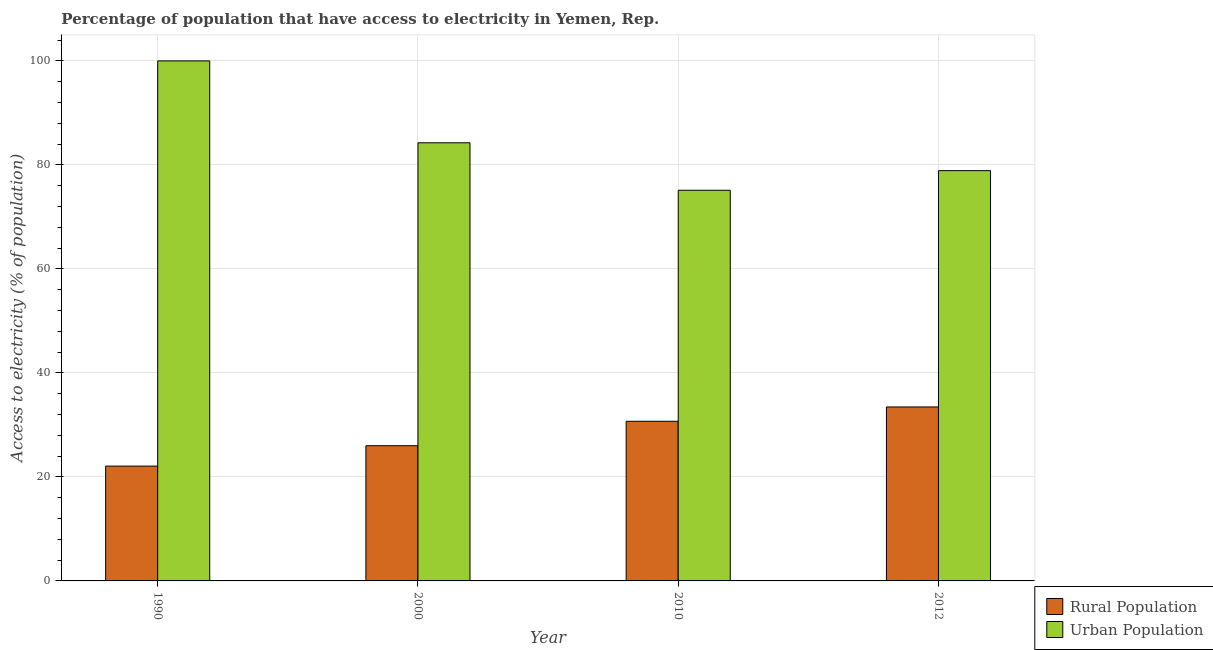Are the number of bars on each tick of the X-axis equal?
Offer a terse response. Yes. How many bars are there on the 1st tick from the left?
Your response must be concise. 2. In how many cases, is the number of bars for a given year not equal to the number of legend labels?
Provide a succinct answer. 0. What is the percentage of urban population having access to electricity in 2012?
Provide a short and direct response. 78.89. Across all years, what is the minimum percentage of rural population having access to electricity?
Ensure brevity in your answer.  22.08. What is the total percentage of urban population having access to electricity in the graph?
Offer a terse response. 338.26. What is the difference between the percentage of rural population having access to electricity in 2010 and that in 2012?
Your answer should be compact. -2.75. What is the difference between the percentage of rural population having access to electricity in 1990 and the percentage of urban population having access to electricity in 2000?
Offer a terse response. -3.92. What is the average percentage of rural population having access to electricity per year?
Offer a terse response. 28.06. What is the ratio of the percentage of rural population having access to electricity in 1990 to that in 2012?
Ensure brevity in your answer.  0.66. Is the percentage of rural population having access to electricity in 2000 less than that in 2010?
Keep it short and to the point. Yes. Is the difference between the percentage of urban population having access to electricity in 2000 and 2010 greater than the difference between the percentage of rural population having access to electricity in 2000 and 2010?
Offer a terse response. No. What is the difference between the highest and the second highest percentage of urban population having access to electricity?
Offer a very short reply. 15.75. What is the difference between the highest and the lowest percentage of urban population having access to electricity?
Keep it short and to the point. 24.88. In how many years, is the percentage of rural population having access to electricity greater than the average percentage of rural population having access to electricity taken over all years?
Keep it short and to the point. 2. What does the 1st bar from the left in 2012 represents?
Ensure brevity in your answer.  Rural Population. What does the 1st bar from the right in 2000 represents?
Keep it short and to the point. Urban Population. How many bars are there?
Keep it short and to the point. 8. How many years are there in the graph?
Offer a very short reply. 4. What is the difference between two consecutive major ticks on the Y-axis?
Provide a succinct answer. 20. Are the values on the major ticks of Y-axis written in scientific E-notation?
Your answer should be very brief. No. Does the graph contain any zero values?
Your response must be concise. No. Where does the legend appear in the graph?
Provide a succinct answer. Bottom right. How many legend labels are there?
Provide a short and direct response. 2. How are the legend labels stacked?
Your answer should be very brief. Vertical. What is the title of the graph?
Offer a very short reply. Percentage of population that have access to electricity in Yemen, Rep. Does "Services" appear as one of the legend labels in the graph?
Offer a terse response. No. What is the label or title of the X-axis?
Ensure brevity in your answer.  Year. What is the label or title of the Y-axis?
Your answer should be compact. Access to electricity (% of population). What is the Access to electricity (% of population) of Rural Population in 1990?
Offer a terse response. 22.08. What is the Access to electricity (% of population) in Urban Population in 1990?
Keep it short and to the point. 100. What is the Access to electricity (% of population) of Urban Population in 2000?
Your answer should be very brief. 84.25. What is the Access to electricity (% of population) of Rural Population in 2010?
Offer a terse response. 30.7. What is the Access to electricity (% of population) in Urban Population in 2010?
Your response must be concise. 75.12. What is the Access to electricity (% of population) in Rural Population in 2012?
Provide a succinct answer. 33.45. What is the Access to electricity (% of population) of Urban Population in 2012?
Make the answer very short. 78.89. Across all years, what is the maximum Access to electricity (% of population) in Rural Population?
Provide a succinct answer. 33.45. Across all years, what is the maximum Access to electricity (% of population) in Urban Population?
Offer a very short reply. 100. Across all years, what is the minimum Access to electricity (% of population) in Rural Population?
Keep it short and to the point. 22.08. Across all years, what is the minimum Access to electricity (% of population) of Urban Population?
Your answer should be very brief. 75.12. What is the total Access to electricity (% of population) of Rural Population in the graph?
Offer a very short reply. 112.23. What is the total Access to electricity (% of population) of Urban Population in the graph?
Offer a terse response. 338.26. What is the difference between the Access to electricity (% of population) of Rural Population in 1990 and that in 2000?
Your answer should be compact. -3.92. What is the difference between the Access to electricity (% of population) in Urban Population in 1990 and that in 2000?
Your answer should be compact. 15.75. What is the difference between the Access to electricity (% of population) of Rural Population in 1990 and that in 2010?
Make the answer very short. -8.62. What is the difference between the Access to electricity (% of population) in Urban Population in 1990 and that in 2010?
Give a very brief answer. 24.88. What is the difference between the Access to electricity (% of population) in Rural Population in 1990 and that in 2012?
Provide a short and direct response. -11.38. What is the difference between the Access to electricity (% of population) in Urban Population in 1990 and that in 2012?
Ensure brevity in your answer.  21.11. What is the difference between the Access to electricity (% of population) of Rural Population in 2000 and that in 2010?
Provide a short and direct response. -4.7. What is the difference between the Access to electricity (% of population) in Urban Population in 2000 and that in 2010?
Make the answer very short. 9.13. What is the difference between the Access to electricity (% of population) in Rural Population in 2000 and that in 2012?
Your response must be concise. -7.45. What is the difference between the Access to electricity (% of population) of Urban Population in 2000 and that in 2012?
Provide a short and direct response. 5.36. What is the difference between the Access to electricity (% of population) of Rural Population in 2010 and that in 2012?
Make the answer very short. -2.75. What is the difference between the Access to electricity (% of population) of Urban Population in 2010 and that in 2012?
Keep it short and to the point. -3.77. What is the difference between the Access to electricity (% of population) of Rural Population in 1990 and the Access to electricity (% of population) of Urban Population in 2000?
Offer a terse response. -62.17. What is the difference between the Access to electricity (% of population) of Rural Population in 1990 and the Access to electricity (% of population) of Urban Population in 2010?
Offer a very short reply. -53.04. What is the difference between the Access to electricity (% of population) in Rural Population in 1990 and the Access to electricity (% of population) in Urban Population in 2012?
Your answer should be compact. -56.81. What is the difference between the Access to electricity (% of population) of Rural Population in 2000 and the Access to electricity (% of population) of Urban Population in 2010?
Offer a terse response. -49.12. What is the difference between the Access to electricity (% of population) in Rural Population in 2000 and the Access to electricity (% of population) in Urban Population in 2012?
Offer a very short reply. -52.89. What is the difference between the Access to electricity (% of population) in Rural Population in 2010 and the Access to electricity (% of population) in Urban Population in 2012?
Ensure brevity in your answer.  -48.19. What is the average Access to electricity (% of population) of Rural Population per year?
Give a very brief answer. 28.06. What is the average Access to electricity (% of population) of Urban Population per year?
Provide a short and direct response. 84.56. In the year 1990, what is the difference between the Access to electricity (% of population) of Rural Population and Access to electricity (% of population) of Urban Population?
Offer a terse response. -77.92. In the year 2000, what is the difference between the Access to electricity (% of population) in Rural Population and Access to electricity (% of population) in Urban Population?
Your answer should be compact. -58.25. In the year 2010, what is the difference between the Access to electricity (% of population) in Rural Population and Access to electricity (% of population) in Urban Population?
Keep it short and to the point. -44.42. In the year 2012, what is the difference between the Access to electricity (% of population) of Rural Population and Access to electricity (% of population) of Urban Population?
Make the answer very short. -45.44. What is the ratio of the Access to electricity (% of population) of Rural Population in 1990 to that in 2000?
Offer a terse response. 0.85. What is the ratio of the Access to electricity (% of population) of Urban Population in 1990 to that in 2000?
Give a very brief answer. 1.19. What is the ratio of the Access to electricity (% of population) in Rural Population in 1990 to that in 2010?
Keep it short and to the point. 0.72. What is the ratio of the Access to electricity (% of population) in Urban Population in 1990 to that in 2010?
Your response must be concise. 1.33. What is the ratio of the Access to electricity (% of population) of Rural Population in 1990 to that in 2012?
Ensure brevity in your answer.  0.66. What is the ratio of the Access to electricity (% of population) of Urban Population in 1990 to that in 2012?
Your answer should be compact. 1.27. What is the ratio of the Access to electricity (% of population) in Rural Population in 2000 to that in 2010?
Keep it short and to the point. 0.85. What is the ratio of the Access to electricity (% of population) of Urban Population in 2000 to that in 2010?
Offer a very short reply. 1.12. What is the ratio of the Access to electricity (% of population) of Rural Population in 2000 to that in 2012?
Offer a very short reply. 0.78. What is the ratio of the Access to electricity (% of population) in Urban Population in 2000 to that in 2012?
Give a very brief answer. 1.07. What is the ratio of the Access to electricity (% of population) of Rural Population in 2010 to that in 2012?
Your answer should be compact. 0.92. What is the ratio of the Access to electricity (% of population) in Urban Population in 2010 to that in 2012?
Your answer should be compact. 0.95. What is the difference between the highest and the second highest Access to electricity (% of population) in Rural Population?
Make the answer very short. 2.75. What is the difference between the highest and the second highest Access to electricity (% of population) in Urban Population?
Your response must be concise. 15.75. What is the difference between the highest and the lowest Access to electricity (% of population) of Rural Population?
Keep it short and to the point. 11.38. What is the difference between the highest and the lowest Access to electricity (% of population) of Urban Population?
Your response must be concise. 24.88. 